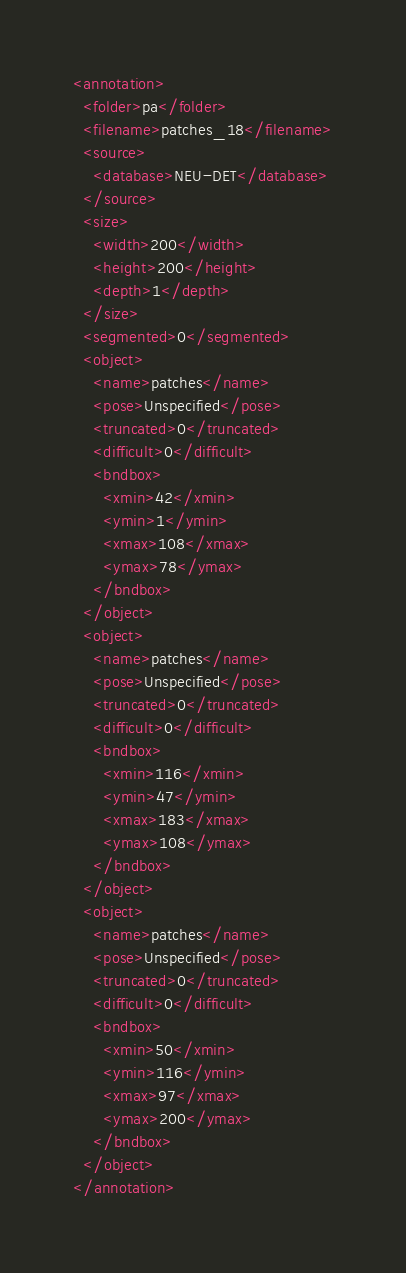Convert code to text. <code><loc_0><loc_0><loc_500><loc_500><_XML_><annotation>
  <folder>pa</folder>
  <filename>patches_18</filename>
  <source>
    <database>NEU-DET</database>
  </source>
  <size>
    <width>200</width>
    <height>200</height>
    <depth>1</depth>
  </size>
  <segmented>0</segmented>
  <object>
    <name>patches</name>
    <pose>Unspecified</pose>
    <truncated>0</truncated>
    <difficult>0</difficult>
    <bndbox>
      <xmin>42</xmin>
      <ymin>1</ymin>
      <xmax>108</xmax>
      <ymax>78</ymax>
    </bndbox>
  </object>
  <object>
    <name>patches</name>
    <pose>Unspecified</pose>
    <truncated>0</truncated>
    <difficult>0</difficult>
    <bndbox>
      <xmin>116</xmin>
      <ymin>47</ymin>
      <xmax>183</xmax>
      <ymax>108</ymax>
    </bndbox>
  </object>
  <object>
    <name>patches</name>
    <pose>Unspecified</pose>
    <truncated>0</truncated>
    <difficult>0</difficult>
    <bndbox>
      <xmin>50</xmin>
      <ymin>116</ymin>
      <xmax>97</xmax>
      <ymax>200</ymax>
    </bndbox>
  </object>
</annotation>
</code> 